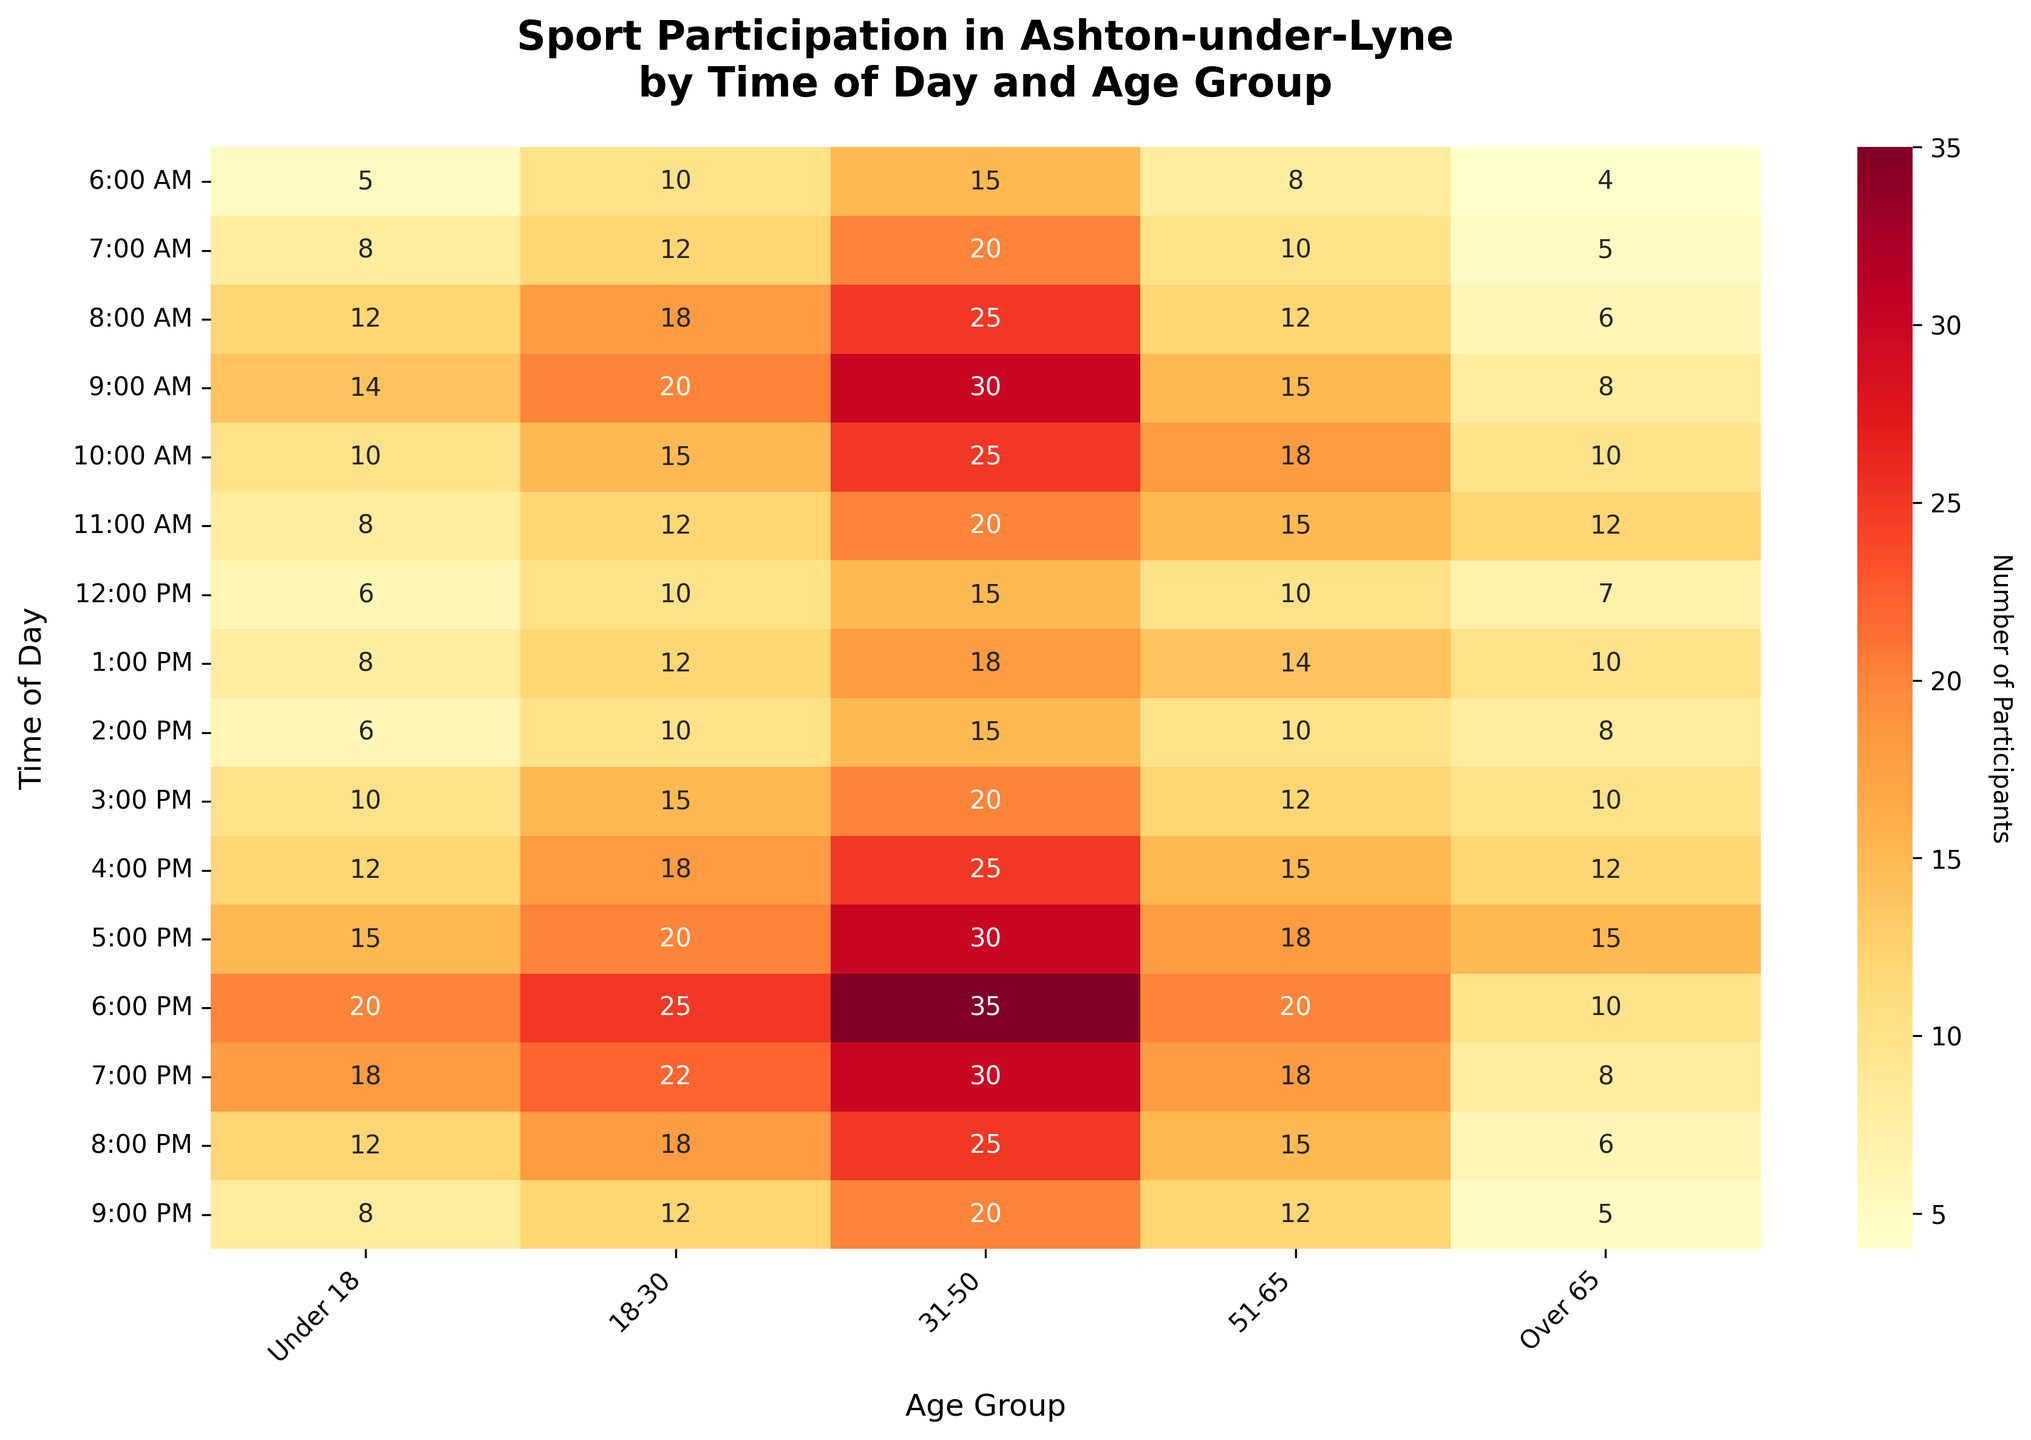What's the title of the figure? The title is usually displayed at the top of the figure. Here, it is clearly written as 'Sport Participation in Ashton-under-Lyne by Time of Day and Age Group'.
Answer: Sport Participation in Ashton-under-Lyne by Time of Day and Age Group Which age group has the highest number of participants at 6:00 PM? To find the age group with the highest number at 6:00 PM, look at the row corresponding to 6:00 PM and find the highest value. The highest value in the row is 35, which belongs to the 31-50 age group.
Answer: 31-50 How many participants are there in the under 18 age group at 8:00 PM? Locate the cell at the intersection of the 'Under 18' column and the '8:00 PM' row. The value in this cell is 12, indicating 12 participants.
Answer: 12 What time of day do participants over 65 have their highest participation? Scan the 'Over 65' column for the highest value. The highest value in this column is 15, found in the 5:00 PM row.
Answer: 5:00 PM Which time of day shows the lowest participation for the 18-30 age group? Look through the '18-30' column and identify the lowest value. The lowest value is 10, found at both 6:00 AM and 12:00 PM.
Answer: 6:00 AM and 12:00 PM What is the total number of participants in the 31-50 age group at 7:00 AM and 6:00 PM? First, find the values for 31-50 at 7:00 AM (20) and 6:00 PM (35). Then, add these values together: 20 + 35 = 55.
Answer: 55 Compare the participation of the 51-65 age group at 9:00 AM and 3:00 PM. Which time has higher participation? Locate the values for 51-65 at 9:00 AM (15) and 3:00 PM (12). Comparing these values, 9:00 AM has higher participation.
Answer: 9:00 AM At what time of day does the 18-30 age group reach their peak participation? Examine the '18-30' column and identify the highest value. The highest value is 25 at 6:00 PM.
Answer: 6:00 PM What is the average number of participants for the over 65 age group across all times? Sum all values in the 'Over 65' column: 4+5+6+8+10+12+7+10+8+10+12+15+10+8+6+5 = 136. Divide this sum by the number of time slots (16): 136/16 = 8.5.
Answer: 8.5 Which time slot has the highest number of total participants across all age groups? Add the values across all age groups for each time slot. 6:00 PM has the highest total: 20+25+35+20+10 = 110.
Answer: 6:00 PM 